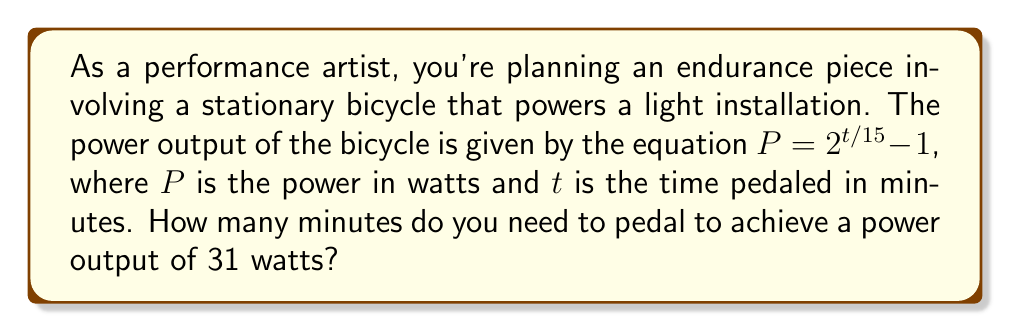What is the answer to this math problem? Let's approach this step-by-step:

1) We're given the equation $P = 2^{t/15} - 1$, where we need to find $t$ when $P = 31$.

2) Let's substitute $P = 31$ into the equation:
   $31 = 2^{t/15} - 1$

3) Add 1 to both sides:
   $32 = 2^{t/15}$

4) Take the logarithm (base 2) of both sides:
   $\log_2(32) = \log_2(2^{t/15})$

5) Simplify the left side:
   $5 = t/15$ (since $2^5 = 32$)

6) Multiply both sides by 15:
   $75 = t$

Therefore, you need to pedal for 75 minutes to achieve a power output of 31 watts.
Answer: 75 minutes 